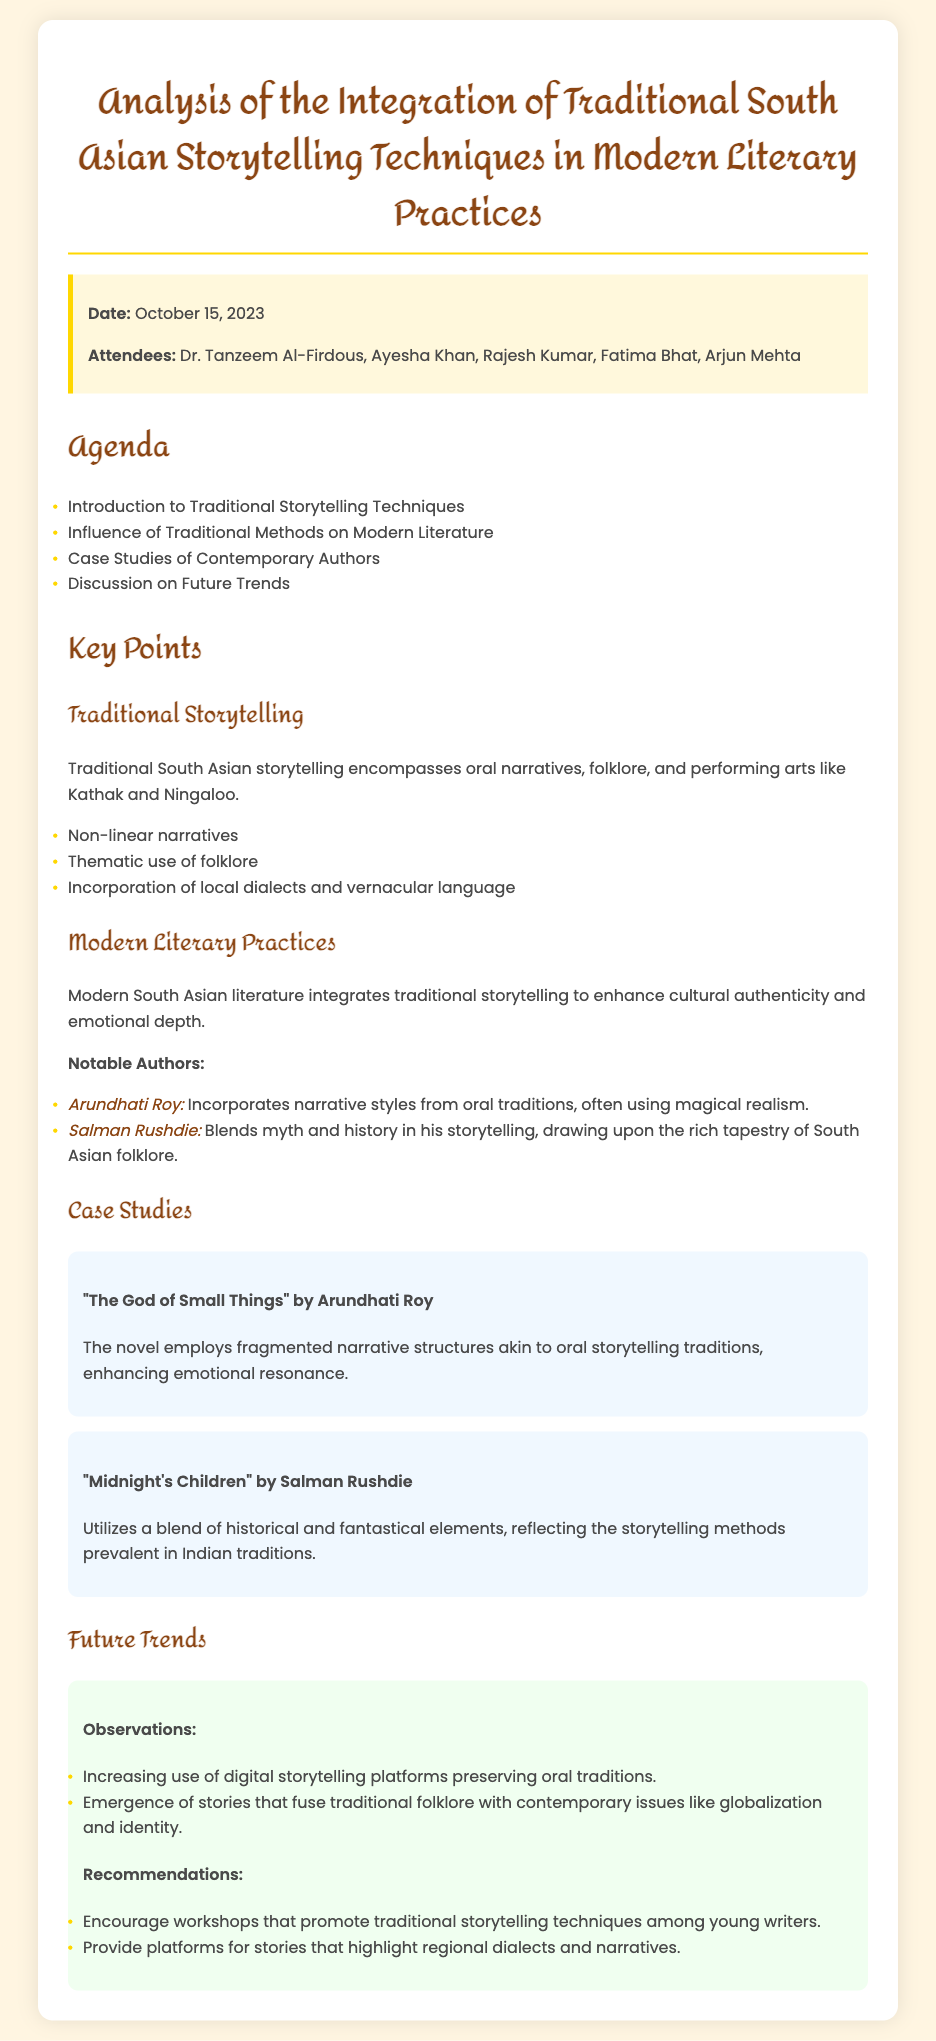what is the date of the meeting? The date of the meeting is mentioned in the document as October 15, 2023.
Answer: October 15, 2023 who is one of the attendees? A list of attendees is provided in the document, one of them is Dr. Tanzeem Al-Firdous.
Answer: Dr. Tanzeem Al-Firdous what is the title of the first case study? The document names the first case study as "The God of Small Things."
Answer: "The God of Small Things" which author incorporates magical realism in their work? The document states that Arundhati Roy incorporates narrative styles from oral traditions, often using magical realism.
Answer: Arundhati Roy what storytelling techniques are emphasized in traditional South Asian storytelling? The document lists several techniques, including non-linear narratives, thematic use of folklore, and incorporation of local dialects.
Answer: Non-linear narratives how many notable authors are mentioned in the modern literary practices section? The document mentions two notable authors concerning modern literary practices.
Answer: Two what future trend involves digital storytelling? The future trends section indicates that there is an increasing use of digital storytelling platforms preserving oral traditions.
Answer: Digital storytelling platforms what is one of the recommendations provided for future practices? The document recommends encouraging workshops that promote traditional storytelling techniques among young writers.
Answer: Workshops for young writers 